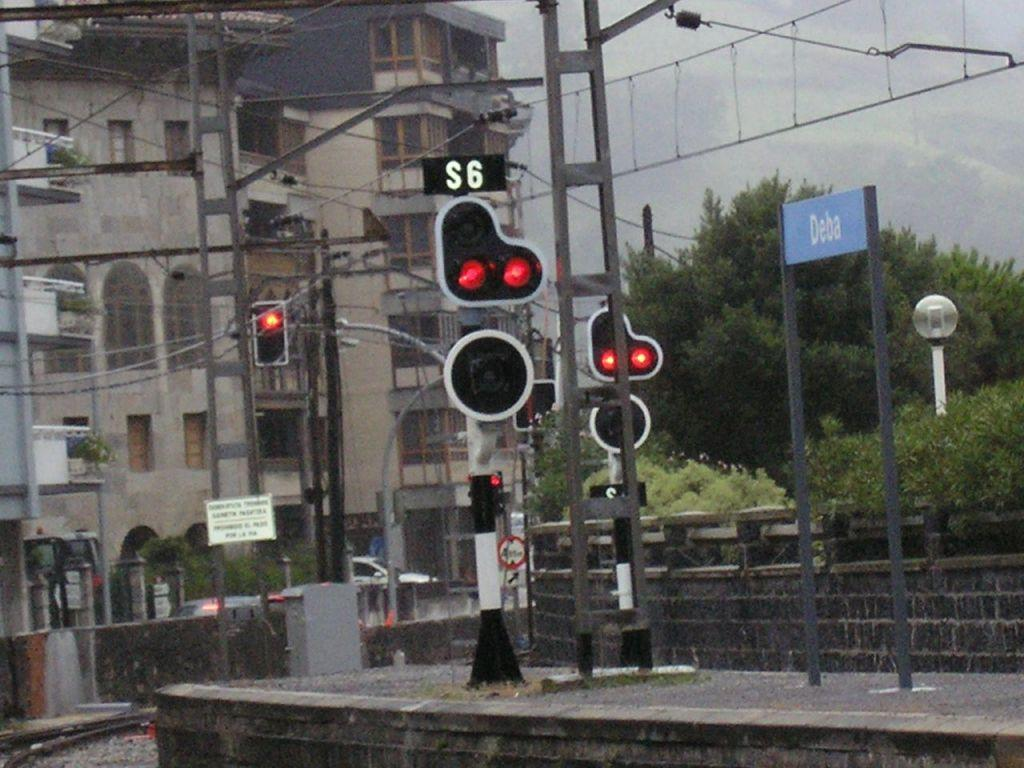<image>
Offer a succinct explanation of the picture presented. A complicated set of traffic lights are next to a blue sign reading Deba. 